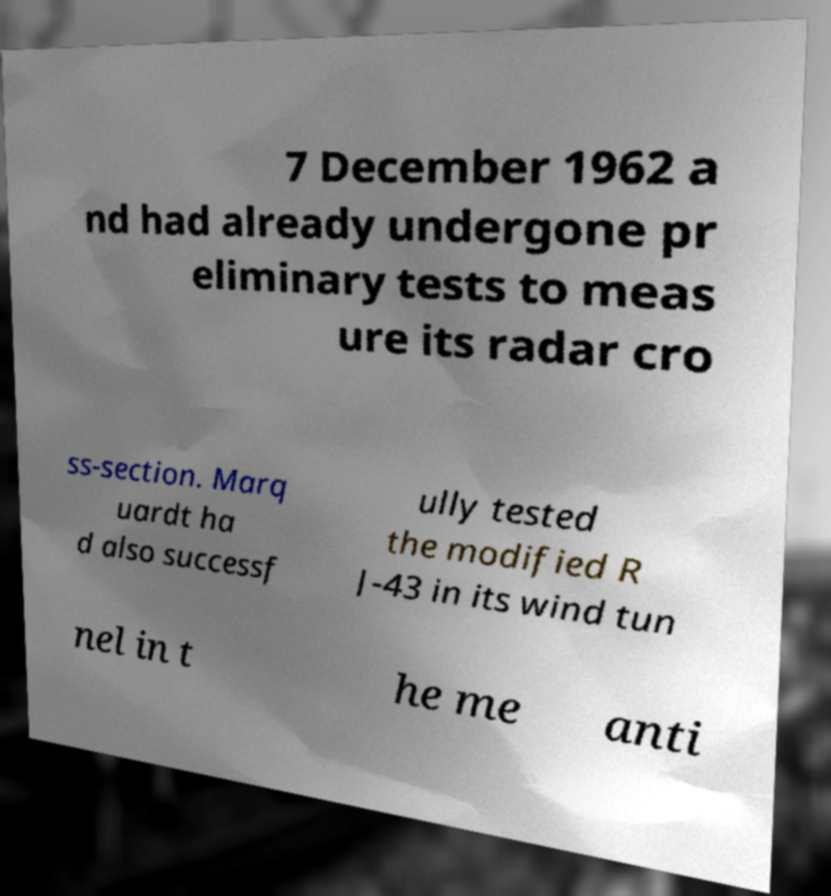I need the written content from this picture converted into text. Can you do that? 7 December 1962 a nd had already undergone pr eliminary tests to meas ure its radar cro ss-section. Marq uardt ha d also successf ully tested the modified R J-43 in its wind tun nel in t he me anti 